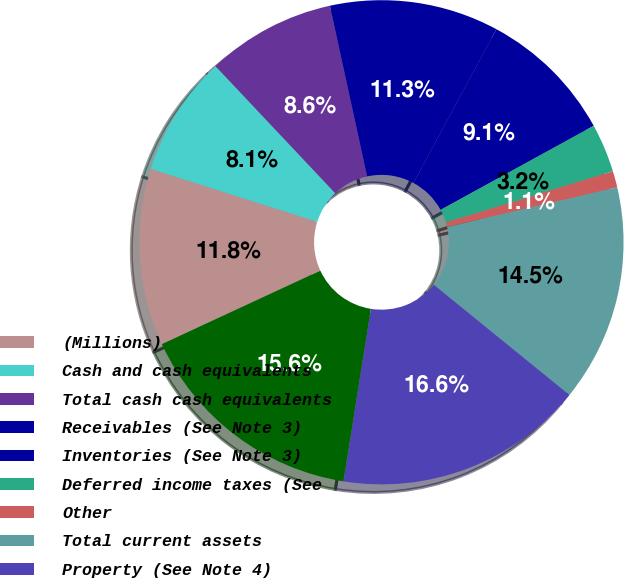Convert chart. <chart><loc_0><loc_0><loc_500><loc_500><pie_chart><fcel>(Millions)<fcel>Cash and cash equivalents<fcel>Total cash cash equivalents<fcel>Receivables (See Note 3)<fcel>Inventories (See Note 3)<fcel>Deferred income taxes (See<fcel>Other<fcel>Total current assets<fcel>Property (See Note 4)<fcel>Less accumulated depreciation<nl><fcel>11.82%<fcel>8.07%<fcel>8.61%<fcel>11.29%<fcel>9.14%<fcel>3.25%<fcel>1.1%<fcel>14.5%<fcel>16.65%<fcel>15.58%<nl></chart> 